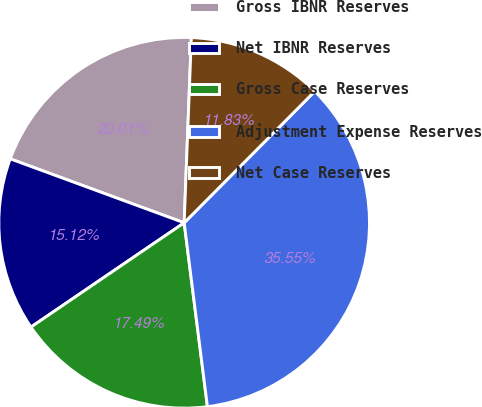Convert chart. <chart><loc_0><loc_0><loc_500><loc_500><pie_chart><fcel>Gross IBNR Reserves<fcel>Net IBNR Reserves<fcel>Gross Case Reserves<fcel>Adjustment Expense Reserves<fcel>Net Case Reserves<nl><fcel>20.01%<fcel>15.12%<fcel>17.49%<fcel>35.55%<fcel>11.83%<nl></chart> 